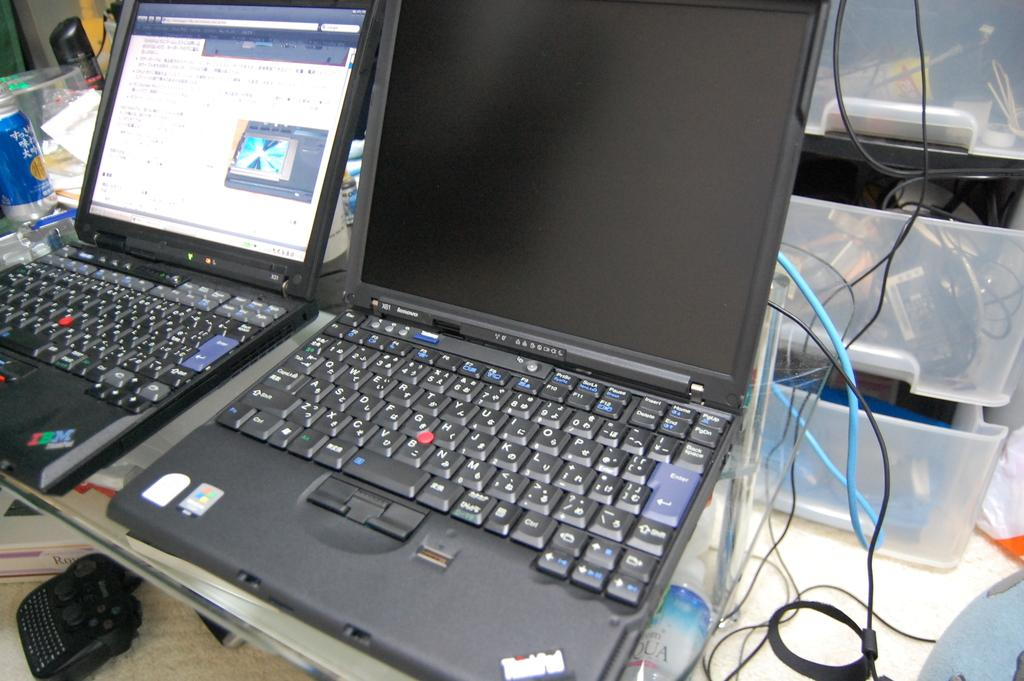<image>
Create a compact narrative representing the image presented. A Lenovo Thinkpad laptop sits at a workspace with another computer. 